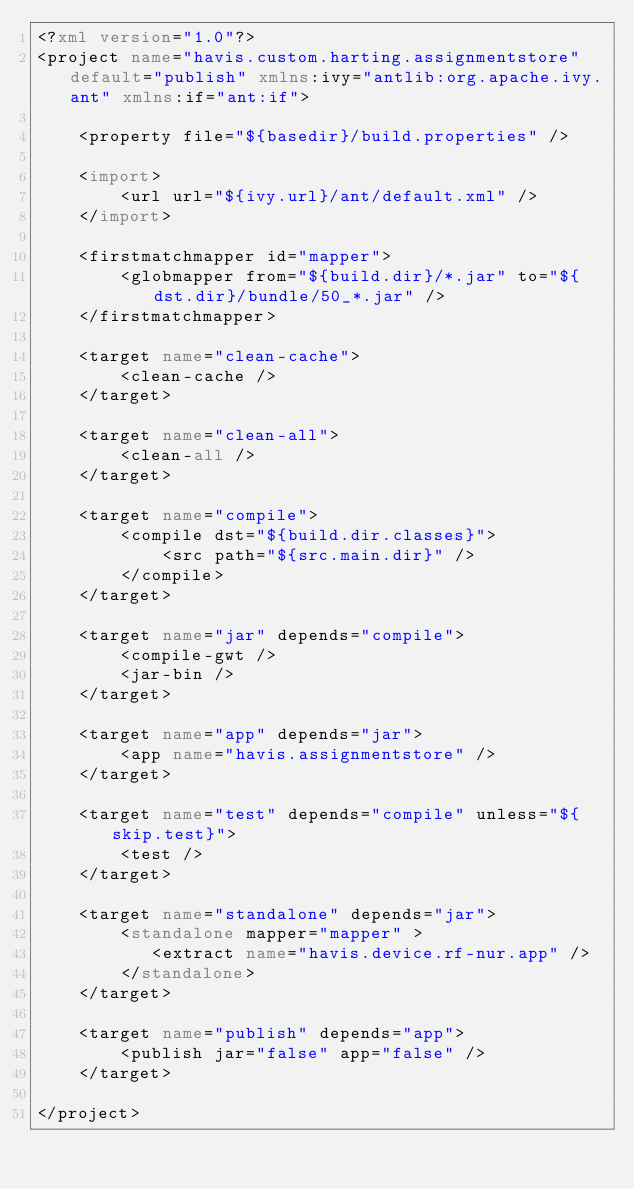Convert code to text. <code><loc_0><loc_0><loc_500><loc_500><_XML_><?xml version="1.0"?>
<project name="havis.custom.harting.assignmentstore" default="publish" xmlns:ivy="antlib:org.apache.ivy.ant" xmlns:if="ant:if">

	<property file="${basedir}/build.properties" />

	<import>
		<url url="${ivy.url}/ant/default.xml" />
	</import>
	
	<firstmatchmapper id="mapper">
		<globmapper from="${build.dir}/*.jar" to="${dst.dir}/bundle/50_*.jar" />
	</firstmatchmapper>

	<target name="clean-cache">
		<clean-cache />
	</target>

	<target name="clean-all">
		<clean-all />
	</target>

	<target name="compile">
		<compile dst="${build.dir.classes}">
			<src path="${src.main.dir}" />
		</compile>
	</target>

	<target name="jar" depends="compile">
		<compile-gwt />
		<jar-bin />
	</target>

	<target name="app" depends="jar">
		<app name="havis.assignmentstore" />
	</target>

	<target name="test" depends="compile" unless="${skip.test}">
		<test />
	</target>

	<target name="standalone" depends="jar">
		<standalone mapper="mapper" >
		   <extract name="havis.device.rf-nur.app" />
		</standalone>
	</target>

	<target name="publish" depends="app">
		<publish jar="false" app="false" />
	</target>

</project>
</code> 